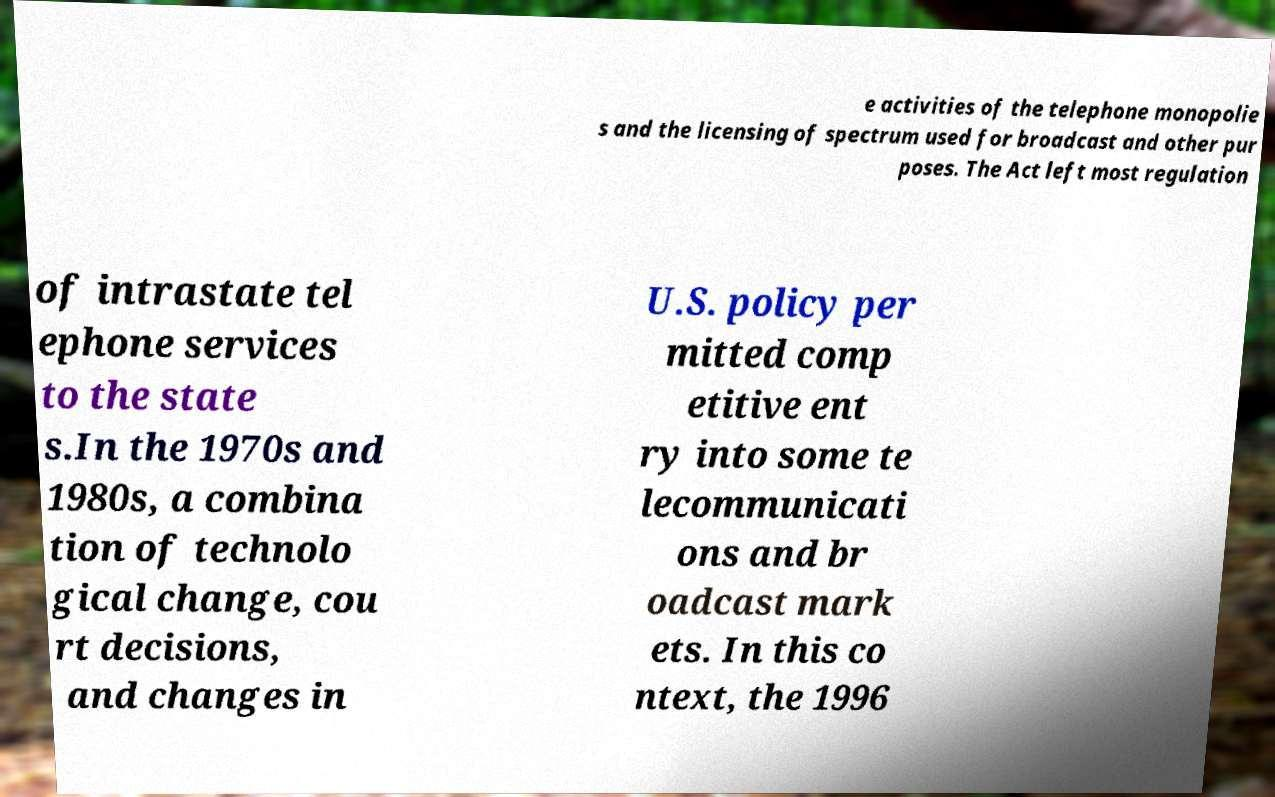There's text embedded in this image that I need extracted. Can you transcribe it verbatim? e activities of the telephone monopolie s and the licensing of spectrum used for broadcast and other pur poses. The Act left most regulation of intrastate tel ephone services to the state s.In the 1970s and 1980s, a combina tion of technolo gical change, cou rt decisions, and changes in U.S. policy per mitted comp etitive ent ry into some te lecommunicati ons and br oadcast mark ets. In this co ntext, the 1996 